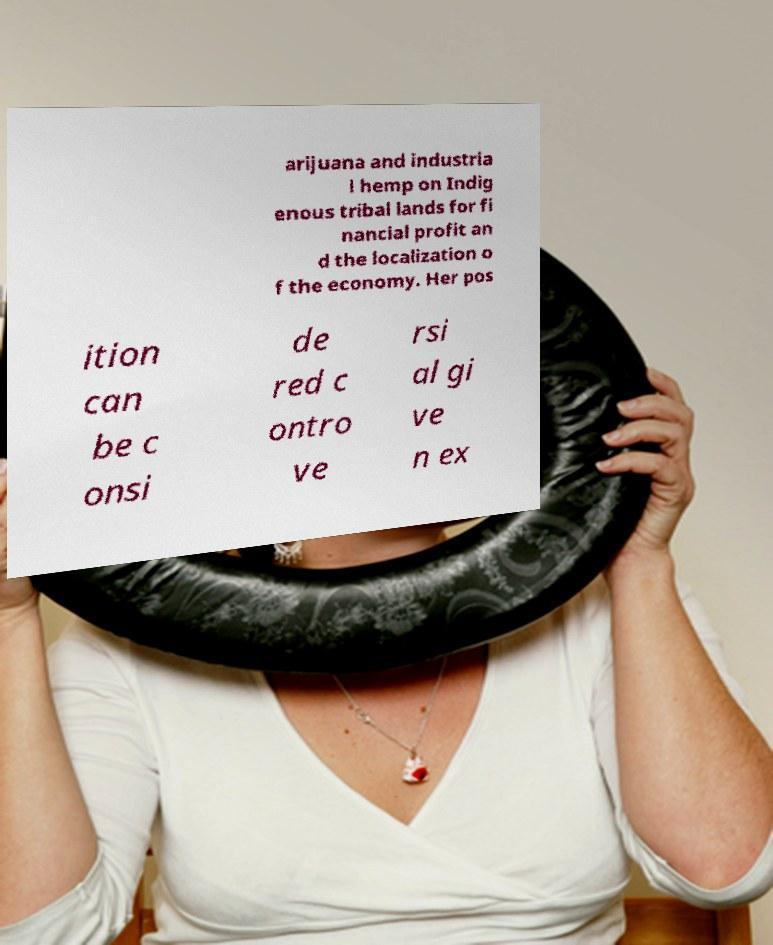There's text embedded in this image that I need extracted. Can you transcribe it verbatim? arijuana and industria l hemp on Indig enous tribal lands for fi nancial profit an d the localization o f the economy. Her pos ition can be c onsi de red c ontro ve rsi al gi ve n ex 